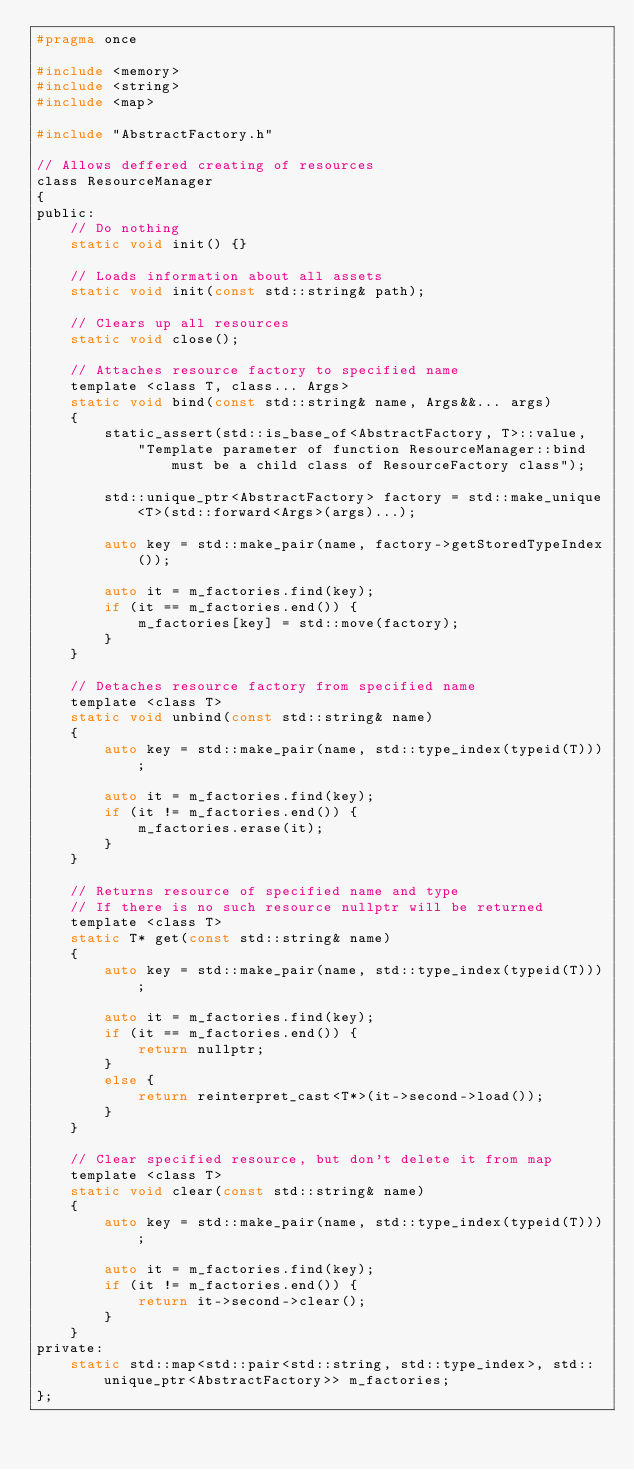<code> <loc_0><loc_0><loc_500><loc_500><_C_>#pragma once

#include <memory>
#include <string>
#include <map>

#include "AbstractFactory.h"

// Allows deffered creating of resources
class ResourceManager
{
public:
	// Do nothing
	static void init() {}
		
	// Loads information about all assets
	static void init(const std::string& path);

	// Clears up all resources
	static void close();

	// Attaches resource factory to specified name
	template <class T, class... Args>
	static void bind(const std::string& name, Args&&... args)
	{
		static_assert(std::is_base_of<AbstractFactory, T>::value,
			"Template parameter of function ResourceManager::bind must be a child class of ResourceFactory class");

		std::unique_ptr<AbstractFactory> factory = std::make_unique<T>(std::forward<Args>(args)...);

		auto key = std::make_pair(name, factory->getStoredTypeIndex());

		auto it = m_factories.find(key);
		if (it == m_factories.end()) {
			m_factories[key] = std::move(factory);
		}
	}

	// Detaches resource factory from specified name
	template <class T>
	static void unbind(const std::string& name)
	{
		auto key = std::make_pair(name, std::type_index(typeid(T)));

		auto it = m_factories.find(key);
		if (it != m_factories.end()) {
			m_factories.erase(it);
		}
	}

	// Returns resource of specified name and type
	// If there is no such resource nullptr will be returned
	template <class T>
	static T* get(const std::string& name)
	{
		auto key = std::make_pair(name, std::type_index(typeid(T)));

		auto it = m_factories.find(key);
		if (it == m_factories.end()) {
			return nullptr;
		}
		else {
			return reinterpret_cast<T*>(it->second->load());
		}
	}

	// Clear specified resource, but don't delete it from map
	template <class T>
	static void clear(const std::string& name)
	{
		auto key = std::make_pair(name, std::type_index(typeid(T)));

		auto it = m_factories.find(key);
		if (it != m_factories.end()) {
			return it->second->clear();
		}
	}
private:
	static std::map<std::pair<std::string, std::type_index>, std::unique_ptr<AbstractFactory>> m_factories;
};</code> 